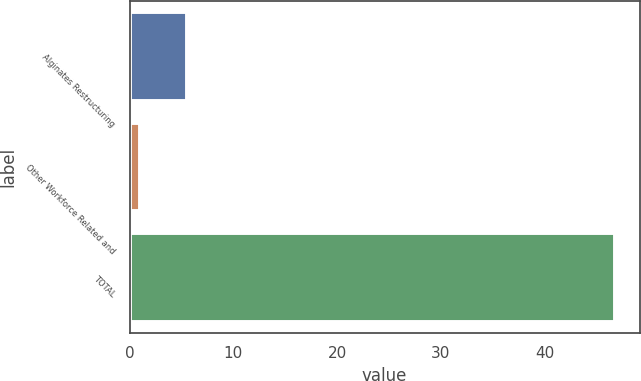Convert chart to OTSL. <chart><loc_0><loc_0><loc_500><loc_500><bar_chart><fcel>Alginates Restructuring<fcel>Other Workforce Related and<fcel>TOTAL<nl><fcel>5.58<fcel>1<fcel>46.8<nl></chart> 